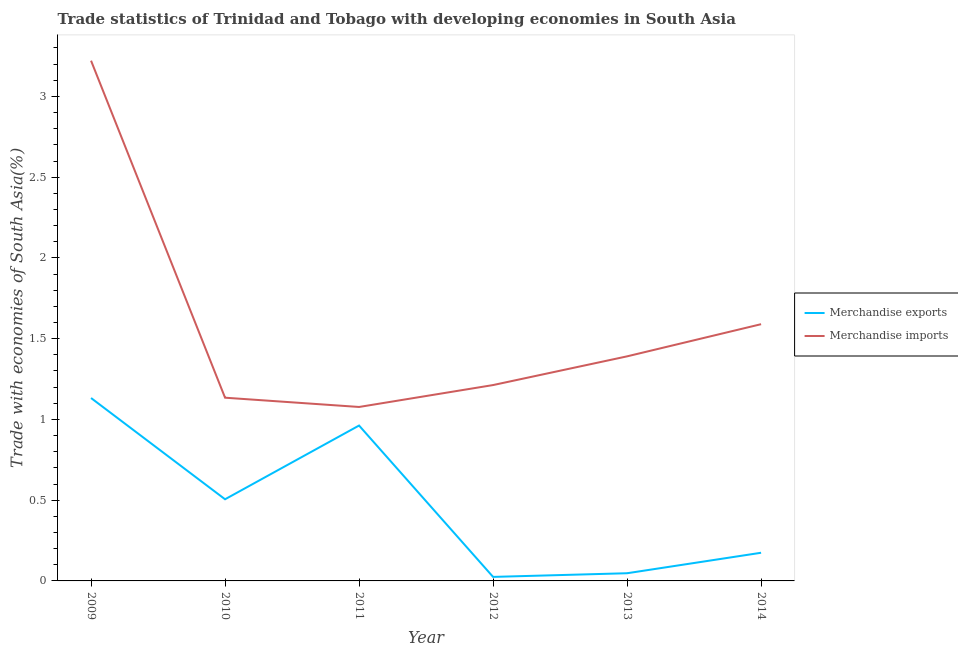How many different coloured lines are there?
Make the answer very short. 2. Does the line corresponding to merchandise exports intersect with the line corresponding to merchandise imports?
Your answer should be very brief. No. Is the number of lines equal to the number of legend labels?
Ensure brevity in your answer.  Yes. What is the merchandise exports in 2012?
Your response must be concise. 0.02. Across all years, what is the maximum merchandise exports?
Your response must be concise. 1.13. Across all years, what is the minimum merchandise imports?
Keep it short and to the point. 1.08. In which year was the merchandise imports maximum?
Keep it short and to the point. 2009. What is the total merchandise exports in the graph?
Your answer should be very brief. 2.85. What is the difference between the merchandise imports in 2009 and that in 2014?
Your answer should be compact. 1.63. What is the difference between the merchandise imports in 2010 and the merchandise exports in 2011?
Give a very brief answer. 0.17. What is the average merchandise exports per year?
Offer a very short reply. 0.47. In the year 2011, what is the difference between the merchandise exports and merchandise imports?
Provide a succinct answer. -0.12. In how many years, is the merchandise imports greater than 2.1 %?
Give a very brief answer. 1. What is the ratio of the merchandise imports in 2010 to that in 2011?
Offer a very short reply. 1.05. Is the merchandise exports in 2011 less than that in 2013?
Provide a succinct answer. No. Is the difference between the merchandise imports in 2012 and 2014 greater than the difference between the merchandise exports in 2012 and 2014?
Provide a succinct answer. No. What is the difference between the highest and the second highest merchandise imports?
Keep it short and to the point. 1.63. What is the difference between the highest and the lowest merchandise imports?
Your answer should be very brief. 2.14. In how many years, is the merchandise imports greater than the average merchandise imports taken over all years?
Offer a terse response. 1. Is the merchandise imports strictly less than the merchandise exports over the years?
Give a very brief answer. No. How many lines are there?
Provide a short and direct response. 2. How many years are there in the graph?
Provide a short and direct response. 6. What is the difference between two consecutive major ticks on the Y-axis?
Keep it short and to the point. 0.5. Does the graph contain any zero values?
Provide a short and direct response. No. Does the graph contain grids?
Provide a succinct answer. No. Where does the legend appear in the graph?
Your response must be concise. Center right. How many legend labels are there?
Your answer should be compact. 2. How are the legend labels stacked?
Offer a terse response. Vertical. What is the title of the graph?
Your answer should be compact. Trade statistics of Trinidad and Tobago with developing economies in South Asia. What is the label or title of the Y-axis?
Give a very brief answer. Trade with economies of South Asia(%). What is the Trade with economies of South Asia(%) in Merchandise exports in 2009?
Your response must be concise. 1.13. What is the Trade with economies of South Asia(%) of Merchandise imports in 2009?
Provide a succinct answer. 3.22. What is the Trade with economies of South Asia(%) of Merchandise exports in 2010?
Offer a very short reply. 0.51. What is the Trade with economies of South Asia(%) of Merchandise imports in 2010?
Your answer should be compact. 1.13. What is the Trade with economies of South Asia(%) in Merchandise exports in 2011?
Give a very brief answer. 0.96. What is the Trade with economies of South Asia(%) in Merchandise imports in 2011?
Provide a succinct answer. 1.08. What is the Trade with economies of South Asia(%) in Merchandise exports in 2012?
Give a very brief answer. 0.02. What is the Trade with economies of South Asia(%) in Merchandise imports in 2012?
Provide a short and direct response. 1.21. What is the Trade with economies of South Asia(%) of Merchandise exports in 2013?
Offer a terse response. 0.05. What is the Trade with economies of South Asia(%) in Merchandise imports in 2013?
Ensure brevity in your answer.  1.39. What is the Trade with economies of South Asia(%) in Merchandise exports in 2014?
Give a very brief answer. 0.17. What is the Trade with economies of South Asia(%) in Merchandise imports in 2014?
Provide a succinct answer. 1.59. Across all years, what is the maximum Trade with economies of South Asia(%) of Merchandise exports?
Your response must be concise. 1.13. Across all years, what is the maximum Trade with economies of South Asia(%) in Merchandise imports?
Give a very brief answer. 3.22. Across all years, what is the minimum Trade with economies of South Asia(%) of Merchandise exports?
Keep it short and to the point. 0.02. Across all years, what is the minimum Trade with economies of South Asia(%) of Merchandise imports?
Give a very brief answer. 1.08. What is the total Trade with economies of South Asia(%) of Merchandise exports in the graph?
Give a very brief answer. 2.85. What is the total Trade with economies of South Asia(%) in Merchandise imports in the graph?
Ensure brevity in your answer.  9.63. What is the difference between the Trade with economies of South Asia(%) of Merchandise exports in 2009 and that in 2010?
Your answer should be very brief. 0.63. What is the difference between the Trade with economies of South Asia(%) in Merchandise imports in 2009 and that in 2010?
Keep it short and to the point. 2.09. What is the difference between the Trade with economies of South Asia(%) in Merchandise exports in 2009 and that in 2011?
Provide a short and direct response. 0.17. What is the difference between the Trade with economies of South Asia(%) of Merchandise imports in 2009 and that in 2011?
Your answer should be very brief. 2.14. What is the difference between the Trade with economies of South Asia(%) in Merchandise exports in 2009 and that in 2012?
Offer a very short reply. 1.11. What is the difference between the Trade with economies of South Asia(%) in Merchandise imports in 2009 and that in 2012?
Keep it short and to the point. 2.01. What is the difference between the Trade with economies of South Asia(%) in Merchandise exports in 2009 and that in 2013?
Make the answer very short. 1.08. What is the difference between the Trade with economies of South Asia(%) in Merchandise imports in 2009 and that in 2013?
Provide a short and direct response. 1.83. What is the difference between the Trade with economies of South Asia(%) in Merchandise exports in 2009 and that in 2014?
Give a very brief answer. 0.96. What is the difference between the Trade with economies of South Asia(%) in Merchandise imports in 2009 and that in 2014?
Keep it short and to the point. 1.63. What is the difference between the Trade with economies of South Asia(%) of Merchandise exports in 2010 and that in 2011?
Offer a terse response. -0.46. What is the difference between the Trade with economies of South Asia(%) of Merchandise imports in 2010 and that in 2011?
Make the answer very short. 0.06. What is the difference between the Trade with economies of South Asia(%) in Merchandise exports in 2010 and that in 2012?
Make the answer very short. 0.48. What is the difference between the Trade with economies of South Asia(%) in Merchandise imports in 2010 and that in 2012?
Your answer should be compact. -0.08. What is the difference between the Trade with economies of South Asia(%) in Merchandise exports in 2010 and that in 2013?
Give a very brief answer. 0.46. What is the difference between the Trade with economies of South Asia(%) of Merchandise imports in 2010 and that in 2013?
Provide a short and direct response. -0.26. What is the difference between the Trade with economies of South Asia(%) of Merchandise exports in 2010 and that in 2014?
Give a very brief answer. 0.33. What is the difference between the Trade with economies of South Asia(%) in Merchandise imports in 2010 and that in 2014?
Provide a short and direct response. -0.46. What is the difference between the Trade with economies of South Asia(%) of Merchandise exports in 2011 and that in 2012?
Provide a short and direct response. 0.94. What is the difference between the Trade with economies of South Asia(%) in Merchandise imports in 2011 and that in 2012?
Your response must be concise. -0.14. What is the difference between the Trade with economies of South Asia(%) in Merchandise exports in 2011 and that in 2013?
Provide a short and direct response. 0.91. What is the difference between the Trade with economies of South Asia(%) of Merchandise imports in 2011 and that in 2013?
Offer a very short reply. -0.31. What is the difference between the Trade with economies of South Asia(%) of Merchandise exports in 2011 and that in 2014?
Your answer should be very brief. 0.79. What is the difference between the Trade with economies of South Asia(%) of Merchandise imports in 2011 and that in 2014?
Keep it short and to the point. -0.51. What is the difference between the Trade with economies of South Asia(%) in Merchandise exports in 2012 and that in 2013?
Your answer should be very brief. -0.02. What is the difference between the Trade with economies of South Asia(%) in Merchandise imports in 2012 and that in 2013?
Your answer should be very brief. -0.18. What is the difference between the Trade with economies of South Asia(%) in Merchandise exports in 2012 and that in 2014?
Keep it short and to the point. -0.15. What is the difference between the Trade with economies of South Asia(%) of Merchandise imports in 2012 and that in 2014?
Keep it short and to the point. -0.38. What is the difference between the Trade with economies of South Asia(%) in Merchandise exports in 2013 and that in 2014?
Offer a terse response. -0.13. What is the difference between the Trade with economies of South Asia(%) in Merchandise imports in 2013 and that in 2014?
Provide a short and direct response. -0.2. What is the difference between the Trade with economies of South Asia(%) of Merchandise exports in 2009 and the Trade with economies of South Asia(%) of Merchandise imports in 2010?
Your answer should be very brief. -0. What is the difference between the Trade with economies of South Asia(%) of Merchandise exports in 2009 and the Trade with economies of South Asia(%) of Merchandise imports in 2011?
Make the answer very short. 0.06. What is the difference between the Trade with economies of South Asia(%) in Merchandise exports in 2009 and the Trade with economies of South Asia(%) in Merchandise imports in 2012?
Your answer should be very brief. -0.08. What is the difference between the Trade with economies of South Asia(%) in Merchandise exports in 2009 and the Trade with economies of South Asia(%) in Merchandise imports in 2013?
Your answer should be very brief. -0.26. What is the difference between the Trade with economies of South Asia(%) in Merchandise exports in 2009 and the Trade with economies of South Asia(%) in Merchandise imports in 2014?
Ensure brevity in your answer.  -0.46. What is the difference between the Trade with economies of South Asia(%) of Merchandise exports in 2010 and the Trade with economies of South Asia(%) of Merchandise imports in 2011?
Your answer should be compact. -0.57. What is the difference between the Trade with economies of South Asia(%) in Merchandise exports in 2010 and the Trade with economies of South Asia(%) in Merchandise imports in 2012?
Ensure brevity in your answer.  -0.71. What is the difference between the Trade with economies of South Asia(%) of Merchandise exports in 2010 and the Trade with economies of South Asia(%) of Merchandise imports in 2013?
Make the answer very short. -0.88. What is the difference between the Trade with economies of South Asia(%) in Merchandise exports in 2010 and the Trade with economies of South Asia(%) in Merchandise imports in 2014?
Give a very brief answer. -1.08. What is the difference between the Trade with economies of South Asia(%) in Merchandise exports in 2011 and the Trade with economies of South Asia(%) in Merchandise imports in 2012?
Offer a terse response. -0.25. What is the difference between the Trade with economies of South Asia(%) of Merchandise exports in 2011 and the Trade with economies of South Asia(%) of Merchandise imports in 2013?
Your response must be concise. -0.43. What is the difference between the Trade with economies of South Asia(%) in Merchandise exports in 2011 and the Trade with economies of South Asia(%) in Merchandise imports in 2014?
Give a very brief answer. -0.63. What is the difference between the Trade with economies of South Asia(%) in Merchandise exports in 2012 and the Trade with economies of South Asia(%) in Merchandise imports in 2013?
Your answer should be very brief. -1.37. What is the difference between the Trade with economies of South Asia(%) in Merchandise exports in 2012 and the Trade with economies of South Asia(%) in Merchandise imports in 2014?
Provide a succinct answer. -1.56. What is the difference between the Trade with economies of South Asia(%) in Merchandise exports in 2013 and the Trade with economies of South Asia(%) in Merchandise imports in 2014?
Offer a terse response. -1.54. What is the average Trade with economies of South Asia(%) in Merchandise exports per year?
Offer a very short reply. 0.47. What is the average Trade with economies of South Asia(%) in Merchandise imports per year?
Your answer should be compact. 1.6. In the year 2009, what is the difference between the Trade with economies of South Asia(%) of Merchandise exports and Trade with economies of South Asia(%) of Merchandise imports?
Ensure brevity in your answer.  -2.09. In the year 2010, what is the difference between the Trade with economies of South Asia(%) of Merchandise exports and Trade with economies of South Asia(%) of Merchandise imports?
Provide a succinct answer. -0.63. In the year 2011, what is the difference between the Trade with economies of South Asia(%) in Merchandise exports and Trade with economies of South Asia(%) in Merchandise imports?
Your answer should be very brief. -0.12. In the year 2012, what is the difference between the Trade with economies of South Asia(%) in Merchandise exports and Trade with economies of South Asia(%) in Merchandise imports?
Your response must be concise. -1.19. In the year 2013, what is the difference between the Trade with economies of South Asia(%) of Merchandise exports and Trade with economies of South Asia(%) of Merchandise imports?
Your answer should be compact. -1.34. In the year 2014, what is the difference between the Trade with economies of South Asia(%) of Merchandise exports and Trade with economies of South Asia(%) of Merchandise imports?
Ensure brevity in your answer.  -1.42. What is the ratio of the Trade with economies of South Asia(%) in Merchandise exports in 2009 to that in 2010?
Keep it short and to the point. 2.24. What is the ratio of the Trade with economies of South Asia(%) in Merchandise imports in 2009 to that in 2010?
Give a very brief answer. 2.84. What is the ratio of the Trade with economies of South Asia(%) in Merchandise exports in 2009 to that in 2011?
Your response must be concise. 1.18. What is the ratio of the Trade with economies of South Asia(%) of Merchandise imports in 2009 to that in 2011?
Offer a terse response. 2.99. What is the ratio of the Trade with economies of South Asia(%) of Merchandise exports in 2009 to that in 2012?
Your response must be concise. 45.47. What is the ratio of the Trade with economies of South Asia(%) in Merchandise imports in 2009 to that in 2012?
Your answer should be very brief. 2.66. What is the ratio of the Trade with economies of South Asia(%) in Merchandise exports in 2009 to that in 2013?
Give a very brief answer. 23.81. What is the ratio of the Trade with economies of South Asia(%) of Merchandise imports in 2009 to that in 2013?
Your answer should be compact. 2.32. What is the ratio of the Trade with economies of South Asia(%) in Merchandise exports in 2009 to that in 2014?
Provide a short and direct response. 6.49. What is the ratio of the Trade with economies of South Asia(%) of Merchandise imports in 2009 to that in 2014?
Your answer should be very brief. 2.03. What is the ratio of the Trade with economies of South Asia(%) in Merchandise exports in 2010 to that in 2011?
Your answer should be compact. 0.53. What is the ratio of the Trade with economies of South Asia(%) of Merchandise imports in 2010 to that in 2011?
Offer a terse response. 1.05. What is the ratio of the Trade with economies of South Asia(%) in Merchandise exports in 2010 to that in 2012?
Ensure brevity in your answer.  20.3. What is the ratio of the Trade with economies of South Asia(%) in Merchandise imports in 2010 to that in 2012?
Ensure brevity in your answer.  0.94. What is the ratio of the Trade with economies of South Asia(%) of Merchandise exports in 2010 to that in 2013?
Your answer should be compact. 10.63. What is the ratio of the Trade with economies of South Asia(%) in Merchandise imports in 2010 to that in 2013?
Provide a succinct answer. 0.82. What is the ratio of the Trade with economies of South Asia(%) in Merchandise exports in 2010 to that in 2014?
Ensure brevity in your answer.  2.9. What is the ratio of the Trade with economies of South Asia(%) in Merchandise imports in 2010 to that in 2014?
Offer a terse response. 0.71. What is the ratio of the Trade with economies of South Asia(%) of Merchandise exports in 2011 to that in 2012?
Provide a succinct answer. 38.62. What is the ratio of the Trade with economies of South Asia(%) of Merchandise imports in 2011 to that in 2012?
Make the answer very short. 0.89. What is the ratio of the Trade with economies of South Asia(%) of Merchandise exports in 2011 to that in 2013?
Your response must be concise. 20.23. What is the ratio of the Trade with economies of South Asia(%) in Merchandise imports in 2011 to that in 2013?
Give a very brief answer. 0.77. What is the ratio of the Trade with economies of South Asia(%) in Merchandise exports in 2011 to that in 2014?
Make the answer very short. 5.52. What is the ratio of the Trade with economies of South Asia(%) in Merchandise imports in 2011 to that in 2014?
Make the answer very short. 0.68. What is the ratio of the Trade with economies of South Asia(%) of Merchandise exports in 2012 to that in 2013?
Give a very brief answer. 0.52. What is the ratio of the Trade with economies of South Asia(%) of Merchandise imports in 2012 to that in 2013?
Ensure brevity in your answer.  0.87. What is the ratio of the Trade with economies of South Asia(%) of Merchandise exports in 2012 to that in 2014?
Your response must be concise. 0.14. What is the ratio of the Trade with economies of South Asia(%) in Merchandise imports in 2012 to that in 2014?
Make the answer very short. 0.76. What is the ratio of the Trade with economies of South Asia(%) of Merchandise exports in 2013 to that in 2014?
Provide a succinct answer. 0.27. What is the ratio of the Trade with economies of South Asia(%) in Merchandise imports in 2013 to that in 2014?
Offer a very short reply. 0.87. What is the difference between the highest and the second highest Trade with economies of South Asia(%) of Merchandise exports?
Provide a succinct answer. 0.17. What is the difference between the highest and the second highest Trade with economies of South Asia(%) in Merchandise imports?
Ensure brevity in your answer.  1.63. What is the difference between the highest and the lowest Trade with economies of South Asia(%) of Merchandise exports?
Offer a terse response. 1.11. What is the difference between the highest and the lowest Trade with economies of South Asia(%) of Merchandise imports?
Give a very brief answer. 2.14. 